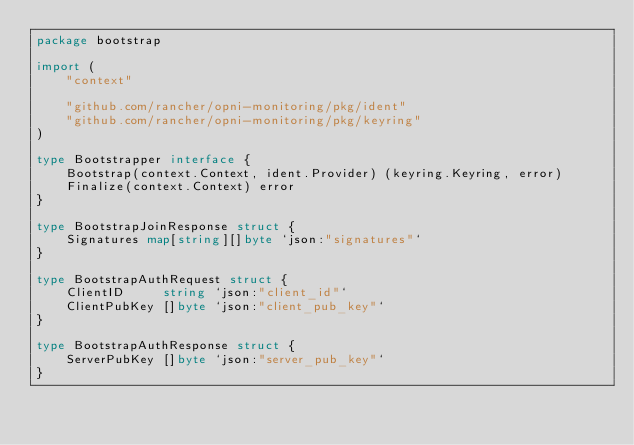<code> <loc_0><loc_0><loc_500><loc_500><_Go_>package bootstrap

import (
	"context"

	"github.com/rancher/opni-monitoring/pkg/ident"
	"github.com/rancher/opni-monitoring/pkg/keyring"
)

type Bootstrapper interface {
	Bootstrap(context.Context, ident.Provider) (keyring.Keyring, error)
	Finalize(context.Context) error
}

type BootstrapJoinResponse struct {
	Signatures map[string][]byte `json:"signatures"`
}

type BootstrapAuthRequest struct {
	ClientID     string `json:"client_id"`
	ClientPubKey []byte `json:"client_pub_key"`
}

type BootstrapAuthResponse struct {
	ServerPubKey []byte `json:"server_pub_key"`
}
</code> 